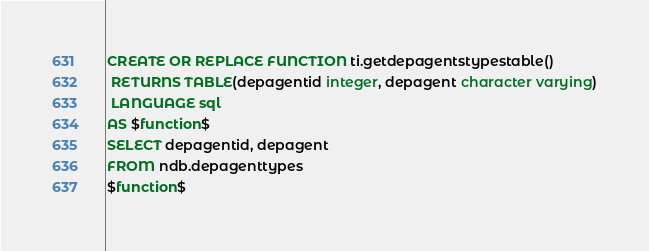<code> <loc_0><loc_0><loc_500><loc_500><_SQL_>CREATE OR REPLACE FUNCTION ti.getdepagentstypestable()
 RETURNS TABLE(depagentid integer, depagent character varying)
 LANGUAGE sql
AS $function$
SELECT depagentid, depagent 
FROM ndb.depagenttypes
$function$
</code> 